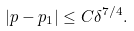<formula> <loc_0><loc_0><loc_500><loc_500>\left | p - p _ { 1 } \right | \leq C \delta ^ { 7 / 4 } .</formula> 